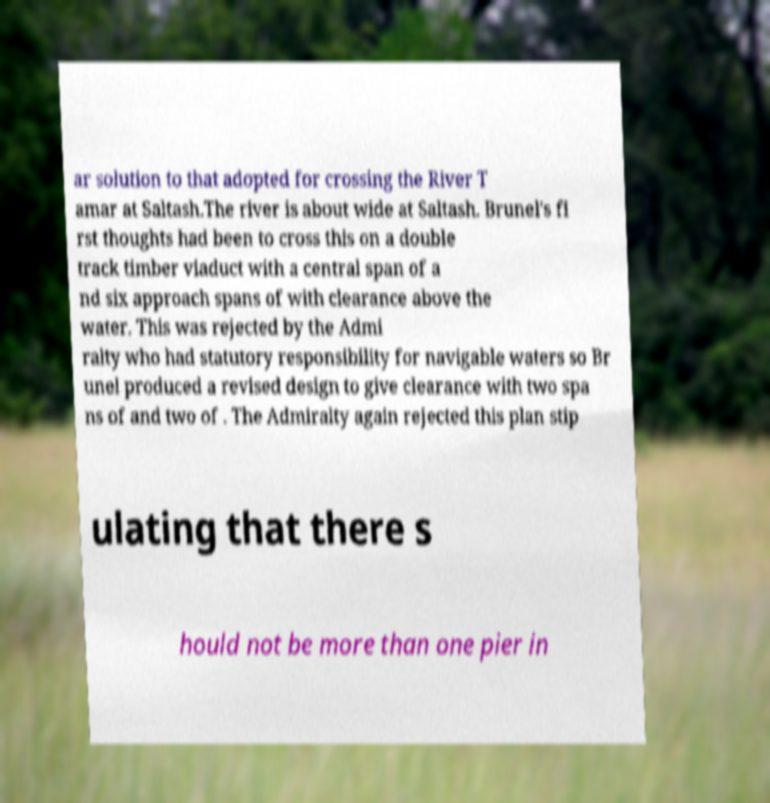Please read and relay the text visible in this image. What does it say? ar solution to that adopted for crossing the River T amar at Saltash.The river is about wide at Saltash. Brunel's fi rst thoughts had been to cross this on a double track timber viaduct with a central span of a nd six approach spans of with clearance above the water. This was rejected by the Admi ralty who had statutory responsibility for navigable waters so Br unel produced a revised design to give clearance with two spa ns of and two of . The Admiralty again rejected this plan stip ulating that there s hould not be more than one pier in 